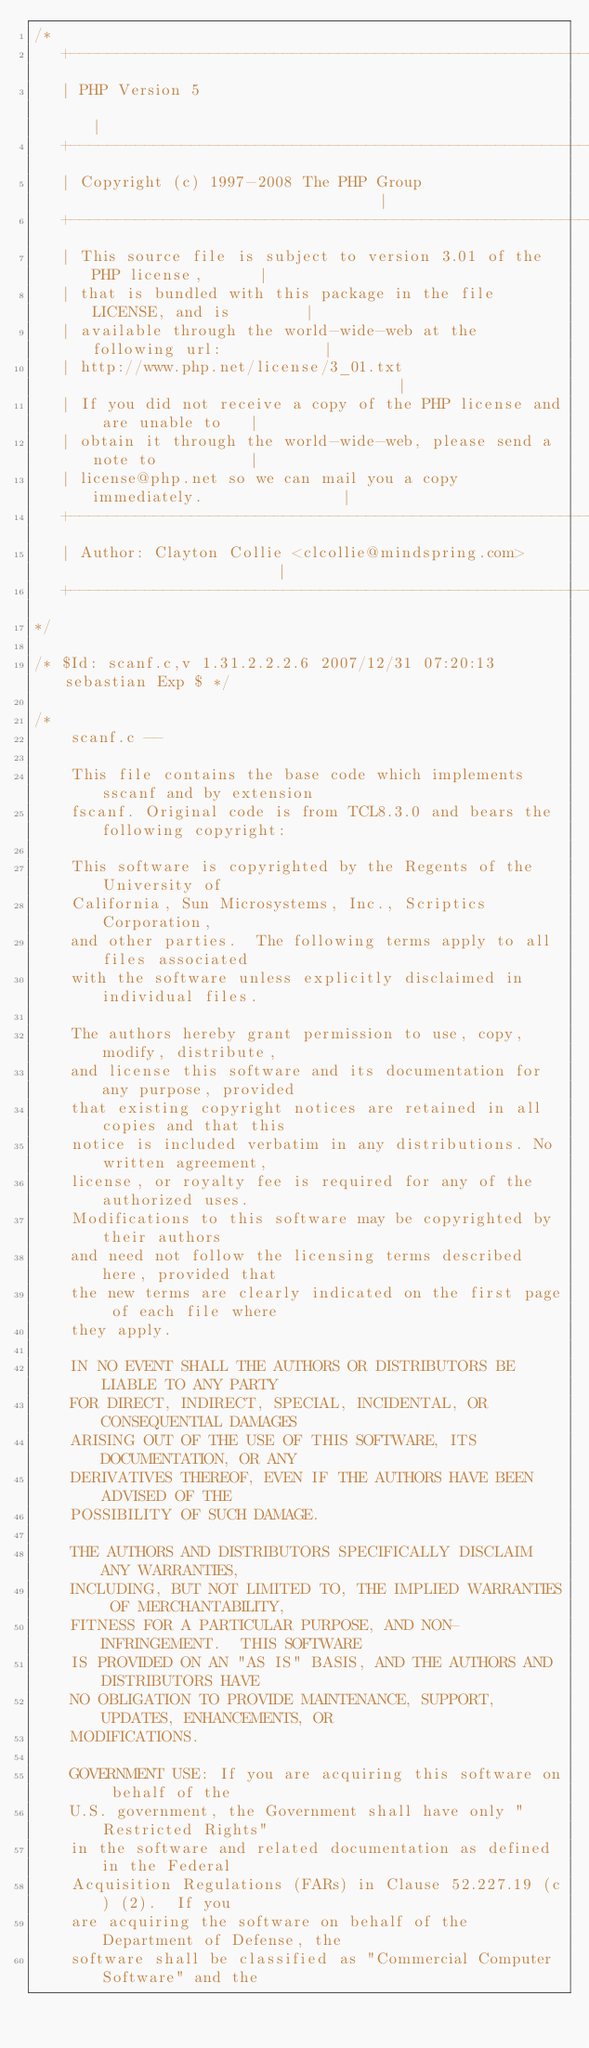Convert code to text. <code><loc_0><loc_0><loc_500><loc_500><_C_>/*
   +----------------------------------------------------------------------+
   | PHP Version 5                                                        |
   +----------------------------------------------------------------------+
   | Copyright (c) 1997-2008 The PHP Group                                |
   +----------------------------------------------------------------------+
   | This source file is subject to version 3.01 of the PHP license,      |
   | that is bundled with this package in the file LICENSE, and is        |
   | available through the world-wide-web at the following url:           |
   | http://www.php.net/license/3_01.txt                                  |
   | If you did not receive a copy of the PHP license and are unable to   |
   | obtain it through the world-wide-web, please send a note to          |
   | license@php.net so we can mail you a copy immediately.               |
   +----------------------------------------------------------------------+
   | Author: Clayton Collie <clcollie@mindspring.com>                     |
   +----------------------------------------------------------------------+
*/

/* $Id: scanf.c,v 1.31.2.2.2.6 2007/12/31 07:20:13 sebastian Exp $ */

/*
	scanf.c --

	This file contains the base code which implements sscanf and by extension
	fscanf. Original code is from TCL8.3.0 and bears the following copyright:

	This software is copyrighted by the Regents of the University of
	California, Sun Microsystems, Inc., Scriptics Corporation,
	and other parties.  The following terms apply to all files associated
	with the software unless explicitly disclaimed in individual files.

	The authors hereby grant permission to use, copy, modify, distribute,
	and license this software and its documentation for any purpose, provided
	that existing copyright notices are retained in all copies and that this
	notice is included verbatim in any distributions. No written agreement,
	license, or royalty fee is required for any of the authorized uses.
	Modifications to this software may be copyrighted by their authors
	and need not follow the licensing terms described here, provided that
	the new terms are clearly indicated on the first page of each file where
	they apply.

	IN NO EVENT SHALL THE AUTHORS OR DISTRIBUTORS BE LIABLE TO ANY PARTY
	FOR DIRECT, INDIRECT, SPECIAL, INCIDENTAL, OR CONSEQUENTIAL DAMAGES
	ARISING OUT OF THE USE OF THIS SOFTWARE, ITS DOCUMENTATION, OR ANY
	DERIVATIVES THEREOF, EVEN IF THE AUTHORS HAVE BEEN ADVISED OF THE
	POSSIBILITY OF SUCH DAMAGE.

	THE AUTHORS AND DISTRIBUTORS SPECIFICALLY DISCLAIM ANY WARRANTIES,
	INCLUDING, BUT NOT LIMITED TO, THE IMPLIED WARRANTIES OF MERCHANTABILITY,
	FITNESS FOR A PARTICULAR PURPOSE, AND NON-INFRINGEMENT.  THIS SOFTWARE
	IS PROVIDED ON AN "AS IS" BASIS, AND THE AUTHORS AND DISTRIBUTORS HAVE
	NO OBLIGATION TO PROVIDE MAINTENANCE, SUPPORT, UPDATES, ENHANCEMENTS, OR
	MODIFICATIONS.

	GOVERNMENT USE: If you are acquiring this software on behalf of the
	U.S. government, the Government shall have only "Restricted Rights"
	in the software and related documentation as defined in the Federal
	Acquisition Regulations (FARs) in Clause 52.227.19 (c) (2).  If you
	are acquiring the software on behalf of the Department of Defense, the
	software shall be classified as "Commercial Computer Software" and the</code> 